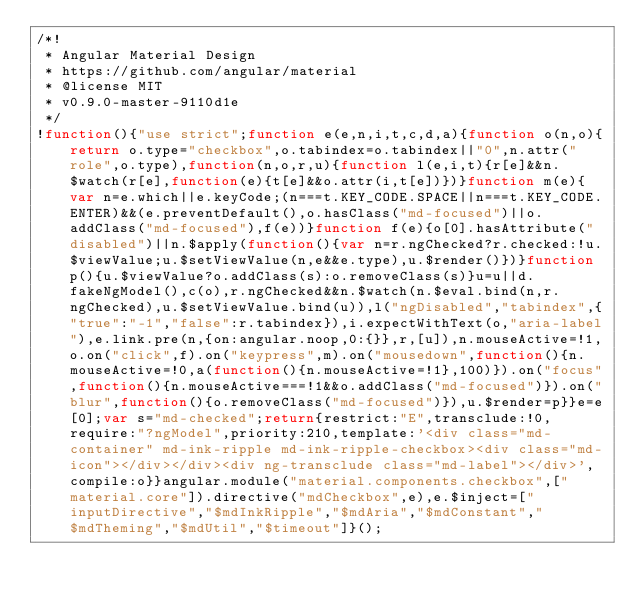<code> <loc_0><loc_0><loc_500><loc_500><_JavaScript_>/*!
 * Angular Material Design
 * https://github.com/angular/material
 * @license MIT
 * v0.9.0-master-9110d1e
 */
!function(){"use strict";function e(e,n,i,t,c,d,a){function o(n,o){return o.type="checkbox",o.tabindex=o.tabindex||"0",n.attr("role",o.type),function(n,o,r,u){function l(e,i,t){r[e]&&n.$watch(r[e],function(e){t[e]&&o.attr(i,t[e])})}function m(e){var n=e.which||e.keyCode;(n===t.KEY_CODE.SPACE||n===t.KEY_CODE.ENTER)&&(e.preventDefault(),o.hasClass("md-focused")||o.addClass("md-focused"),f(e))}function f(e){o[0].hasAttribute("disabled")||n.$apply(function(){var n=r.ngChecked?r.checked:!u.$viewValue;u.$setViewValue(n,e&&e.type),u.$render()})}function p(){u.$viewValue?o.addClass(s):o.removeClass(s)}u=u||d.fakeNgModel(),c(o),r.ngChecked&&n.$watch(n.$eval.bind(n,r.ngChecked),u.$setViewValue.bind(u)),l("ngDisabled","tabindex",{"true":"-1","false":r.tabindex}),i.expectWithText(o,"aria-label"),e.link.pre(n,{on:angular.noop,0:{}},r,[u]),n.mouseActive=!1,o.on("click",f).on("keypress",m).on("mousedown",function(){n.mouseActive=!0,a(function(){n.mouseActive=!1},100)}).on("focus",function(){n.mouseActive===!1&&o.addClass("md-focused")}).on("blur",function(){o.removeClass("md-focused")}),u.$render=p}}e=e[0];var s="md-checked";return{restrict:"E",transclude:!0,require:"?ngModel",priority:210,template:'<div class="md-container" md-ink-ripple md-ink-ripple-checkbox><div class="md-icon"></div></div><div ng-transclude class="md-label"></div>',compile:o}}angular.module("material.components.checkbox",["material.core"]).directive("mdCheckbox",e),e.$inject=["inputDirective","$mdInkRipple","$mdAria","$mdConstant","$mdTheming","$mdUtil","$timeout"]}();</code> 